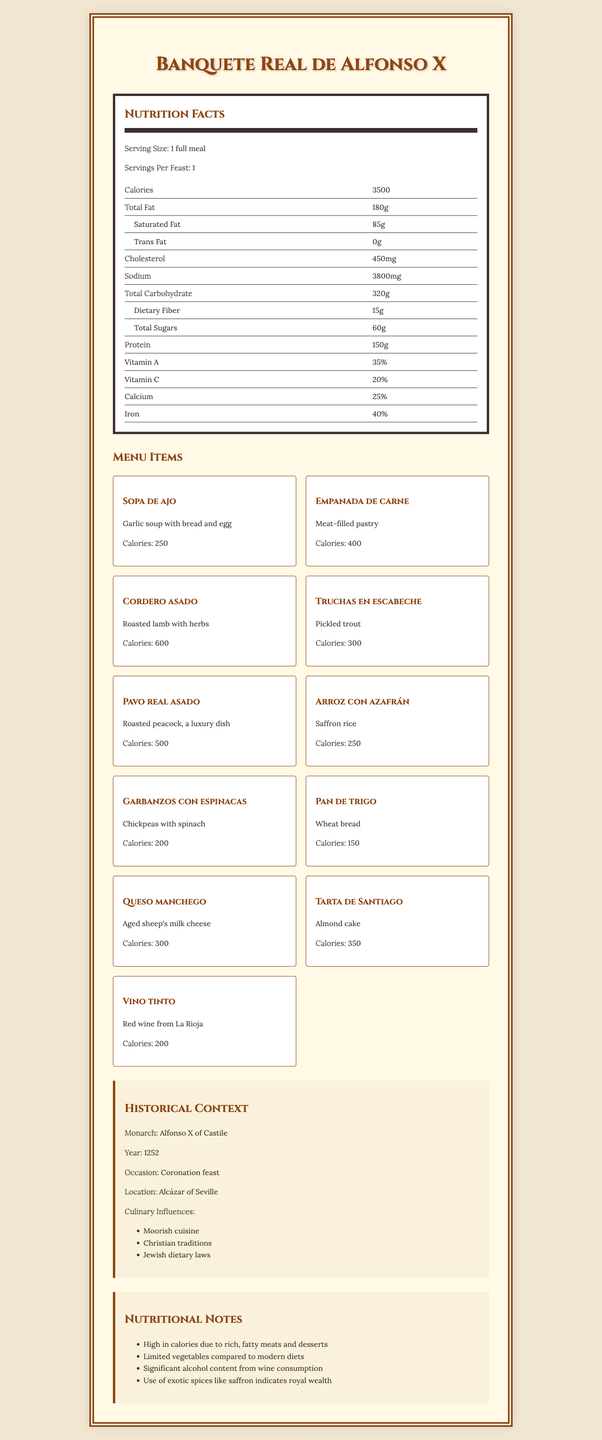who is the monarch associated with the feast? The document explicitly mentions that the monarch for the feast is Alfonso X of Castile under the historical context section.
Answer: Alfonso X of Castile what is the serving size of the feast? The serving size is given as "1 full meal" under the "Nutrition Facts" section.
Answer: 1 full meal how many calories does the entire feast provide? The "Nutrition Facts" section lists the total calories for the feast as 3500.
Answer: 3500 name one of the dishes that has a description involving herbs. In the menu items section, "Cordero asado" is described as "Roasted lamb with herbs."
Answer: Cordero asado which dish contributes the highest number of calories? The "Cordero asado" provides 600 calories, which is the highest among all the dishes listed in the menu items.
Answer: Cordero asado how many milligrams of sodium are in the feast? The "Nutrition Facts" section lists the sodium content as 3800mg.
Answer: 3800mg which of the following is a luxury dish? A. Sopa de ajo B. Pavo real asado C. Pan de trigo The description for "Pavo real asado" identifies it as a luxury dish.
Answer: B. Pavo real asado which dietary law influenced the feast menu? A. Christian traditions B. Buddhist ethics C. Vegan principles The document lists "Christian traditions" as one of the culinary influences.
Answer: A. Christian traditions was wine part of the feast menu? "Vino tinto" (red wine) is listed as one of the menu items.
Answer: Yes summarize the nutritional components of the feast menu. The document details the feast's high calorie and rich nutrient content, listing specific foods and beverages offered. High fat, cholesterol, and sodium levels suggest indulgence typical of royal feasts.
Answer: The feast menu provides 3500 calories, with high amounts of total fat, cholesterol, and sodium. It includes individual nutritional details such as 180g of total fat, 85g of saturated fat, and 60g of total sugars. The feast menu consists of various rich and exotic foods, reflecting royal wealth and cultural influences. what specific occasion was the feast held for? The document specifies that the feast was held for a "Coronation feast" under the historical context section.
Answer: Coronation feast how many menu items are there in the feast? The document lists 11 menu items in the feast.
Answer: 11 is there an exact breakdown of the percentage daily values for all nutrients? While some nutrients like Vitamin A, Vitamin C, Calcium, and Iron are listed with percentages, others like total fat, carbohydrate, and protein do not have their daily value percentages provided.
Answer: No what are the main historical influences on the menu? The document lists these influences as the main culinary influences on the feast menu.
Answer: Moorish cuisine, Christian traditions, Jewish dietary laws calculate the average calorie contribution of each menu item. The total calories from all menu items add up to 3500. Dividing 3500 by 11 (the number of menu items) gives approximately 318 calories per item.
Answer: 318 who would have enjoyed this feast? The document does not provide specific details on the guests or social strata of the individuals who would have partaken in this feast.
Answer: Not enough information 